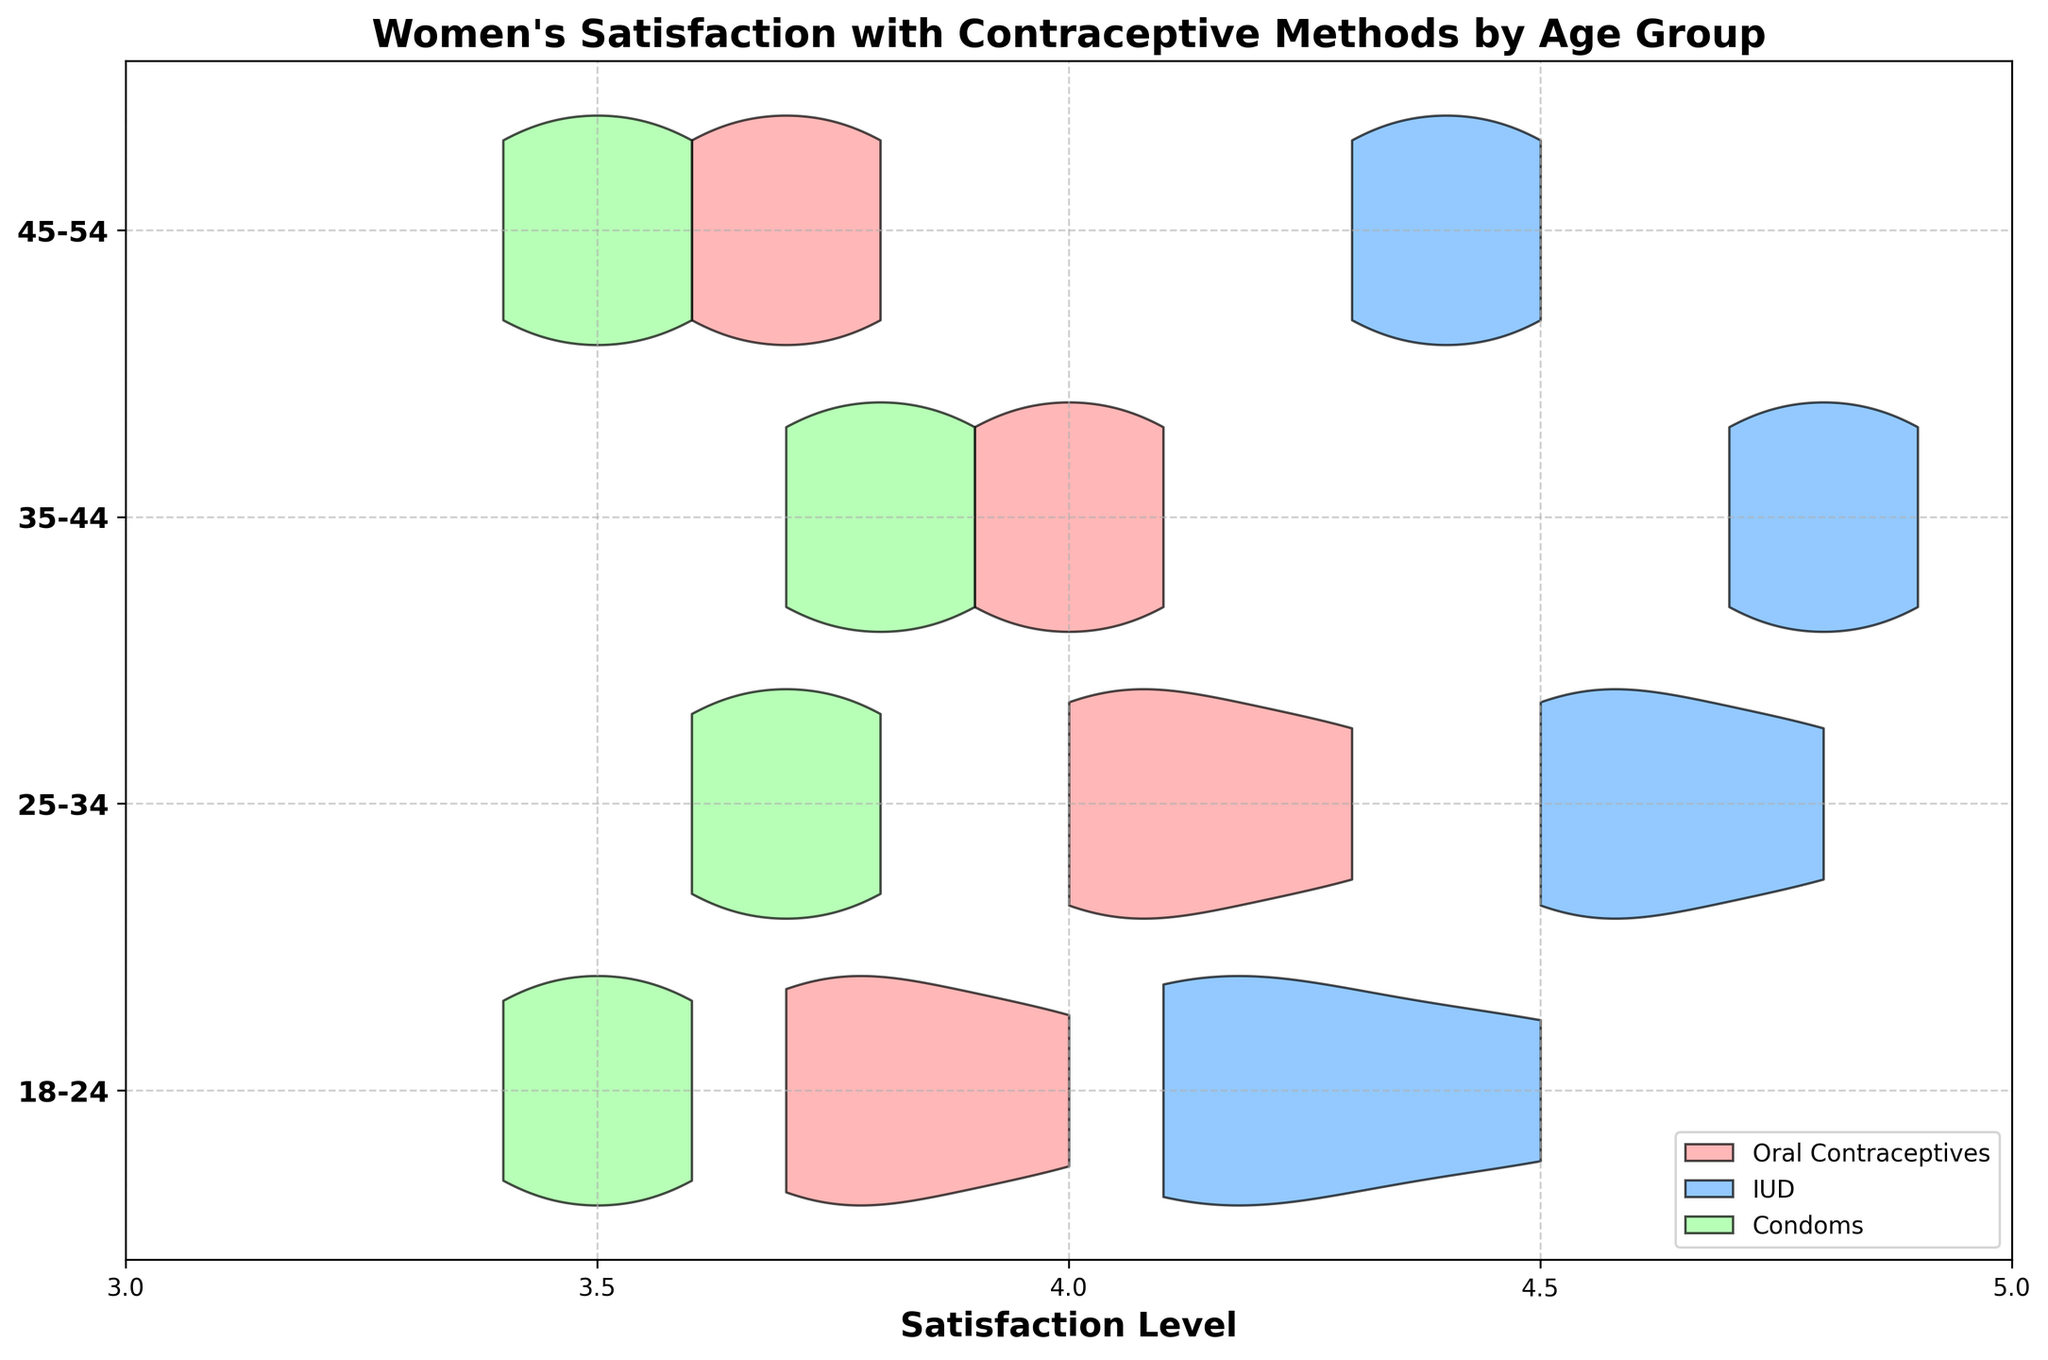What's the title of the chart? The title is displayed at the top of the chart, indicating the purpose of the graph.
Answer: Women's Satisfaction with Contraceptive Methods by Age Group What are the age groups represented on the y-axis of the chart? The age groups are labeled on the y-axis, showing the categories being plotted for comparison.
Answer: 18-24, 25-34, 35-44, 45-54 Which contraceptive method has the highest average satisfaction level in the age group 35-44? By examining the violins for the age group 35-44, we look at the highest average position. The IUD method has the highest position in this age group.
Answer: IUD What is the range of the x-axis representing satisfaction levels? The x-axis represents satisfaction levels, marked with labels to indicate the scale and range.
Answer: 3 to 5 Which age group shows the most variance in satisfaction levels for IUDs? Variance can be observed by the spread of the violin plots. The age group with the widest spread for IUDs indicates the most variance.
Answer: 18-24 Between which two age groups is the satisfaction level for Oral Contraceptives more similar? Comparing the positions of the violin plots for Oral Contraceptives, the two age groups with the closest range have similar satisfaction levels.
Answer: 18-24 and 45-54 How does the satisfaction level for Condoms trend across the age groups? Observing the position and shape of the violin plots for Condoms across age groups, we can see that the levels remain fairly consistent but slightly increase with age.
Answer: Consistent with a slight increase Which contraceptive method shows the least variation in satisfaction levels within the age group 25-34? The least variation is indicated by the narrowest violin plot. For age group 25-34, this is shown by looking at the tightest or smallest spread.
Answer: Oral Contraceptives What can be inferred about the overall satisfaction with IUDs across different age groups compared to other methods? By observing the general position and spread of the violin plots for IUDs, we can infer that IUDs generally have higher satisfaction levels across all age groups compared to other methods.
Answer: Higher satisfaction levels How many contraceptive methods are displayed in the chart and what are their colors? The legend at the bottom of the chart indicates the different contraceptive methods by color. There are three methods displayed.
Answer: Three methods: Oral Contraceptives (pink), IUD (blue), Condoms (green) 